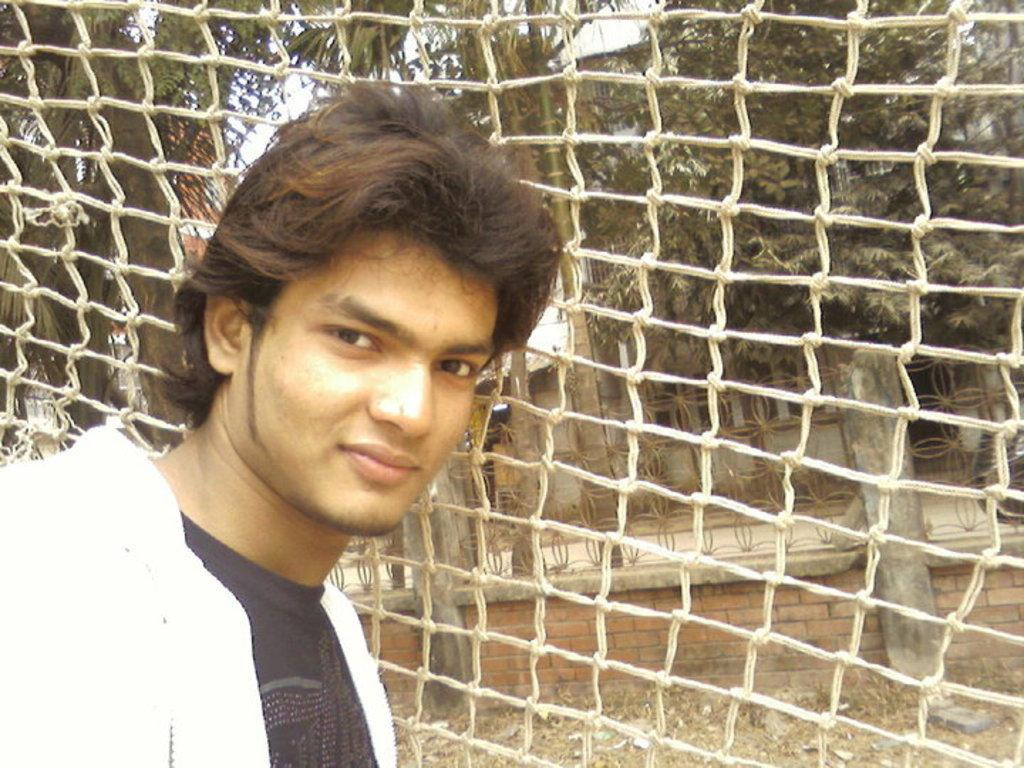What is the main subject of the image? There is a man standing in the image. Where is the man standing? The man is standing on a path. What can be seen in the image besides the man? There is a net visible in the image. What is visible in the background of the image? There are trees, houses, and the sky visible in the background of the image. What type of soap is the man using to bite in the image? There is no soap or biting action present in the image. Can you tell me how many uncles are in the image? There is no mention of an uncle or any family members in the image. 